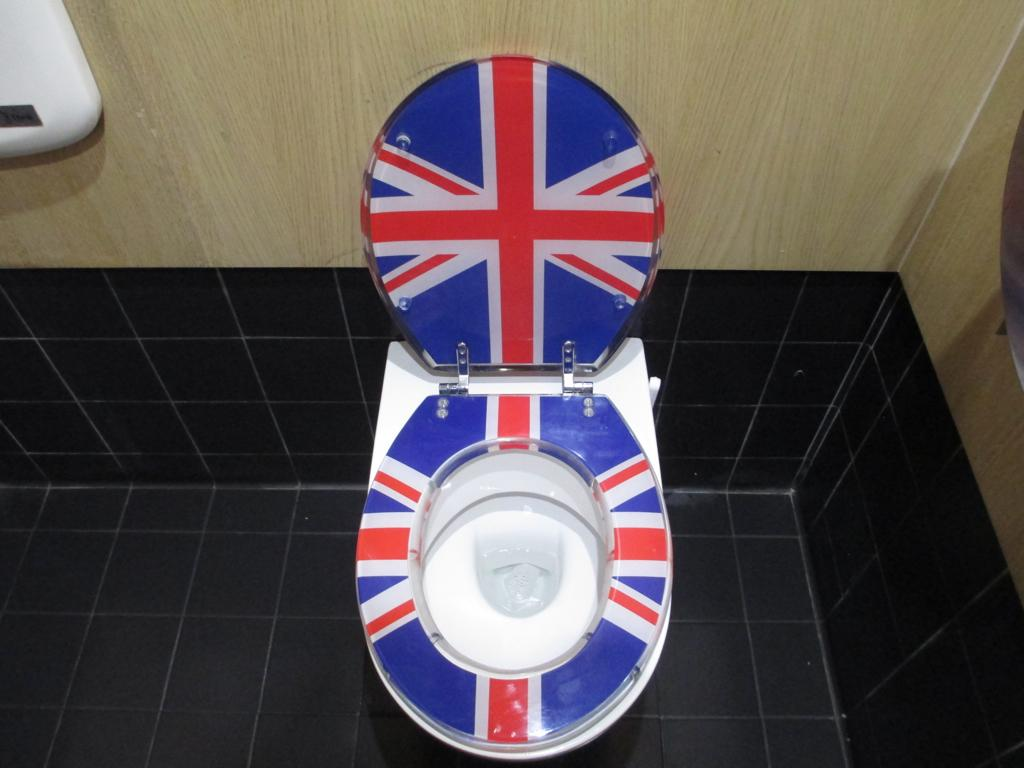What is the main object in the image? There is a toilet seat in the image. What can be seen surrounding the toilet seat? There are walls visible in the image. How many noses can be seen on the toilet seat in the image? There are no noses present on the toilet seat in the image. Are there any bikes visible in the image? There is no mention of bikes in the provided facts, and therefore no bikes can be seen in the image. 